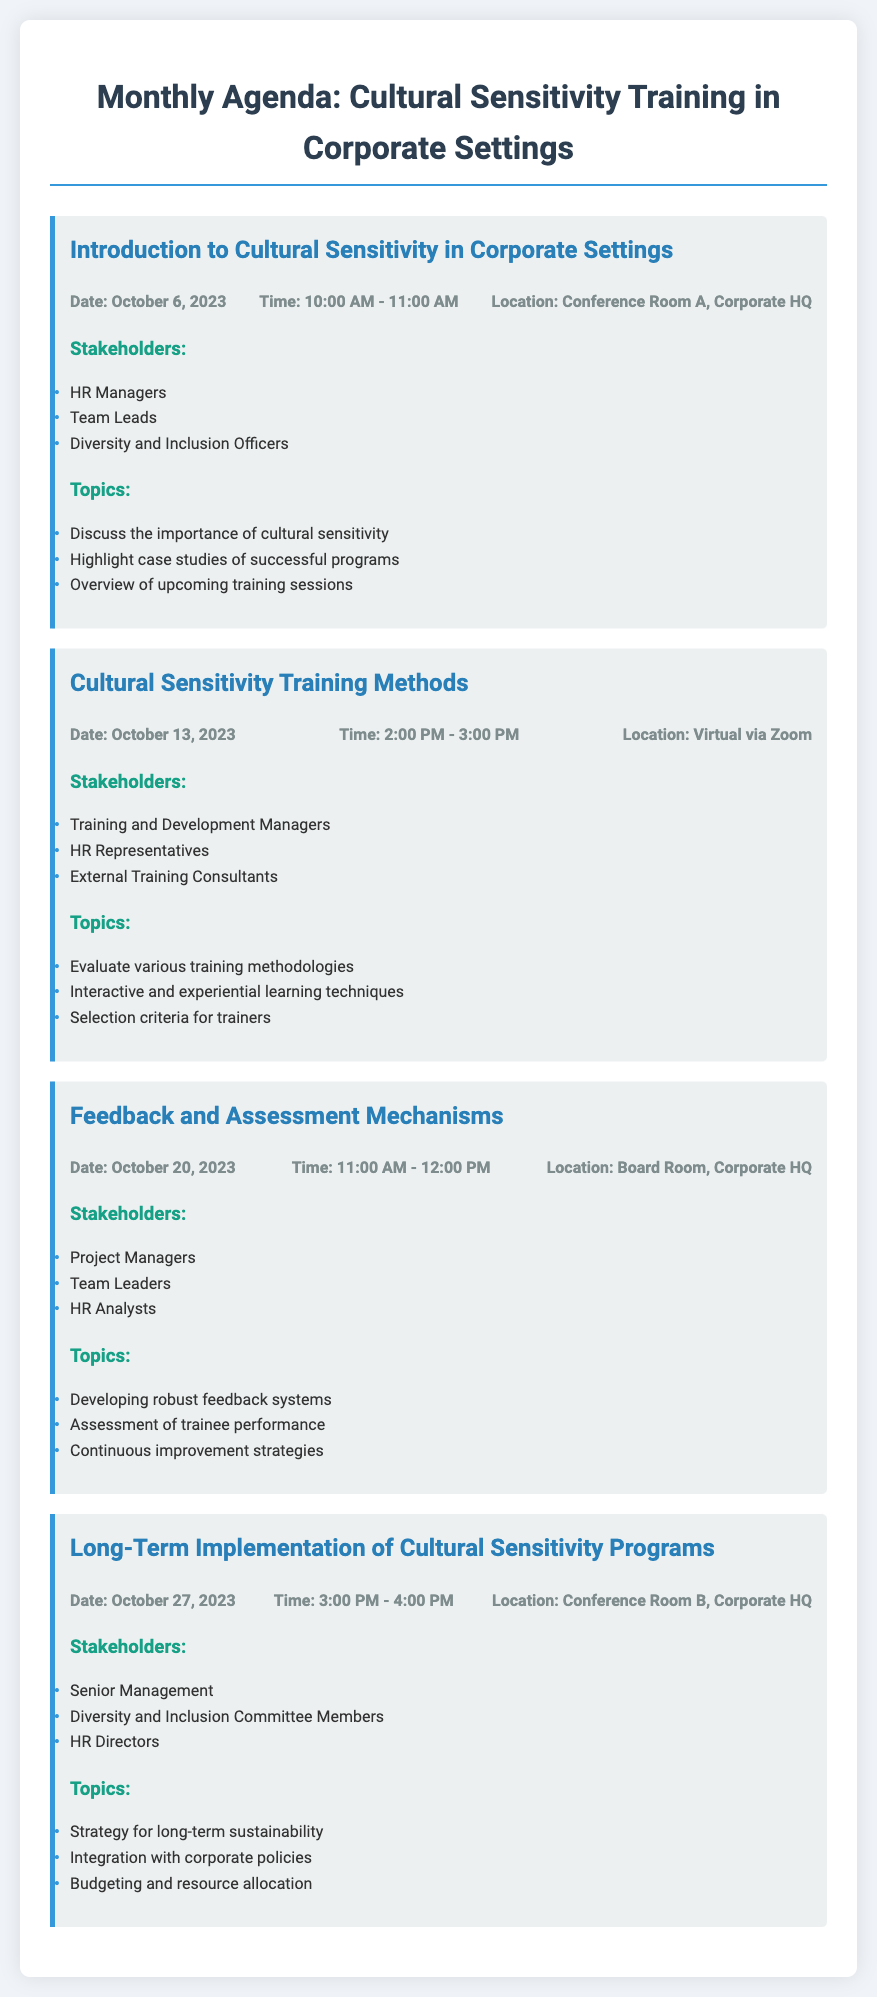What is the date of the first meeting? The first meeting is scheduled for October 6, 2023, as mentioned in the document.
Answer: October 6, 2023 Who is responsible for leading the second meeting? The second meeting involves Training and Development Managers, HR Representatives, and External Training Consultants, indicating leadership roles.
Answer: Training and Development Managers What is the location of the third meeting? The document specifies that the third meeting will take place in the Board Room at Corporate HQ.
Answer: Board Room, Corporate HQ What time is the last meeting scheduled for? The last meeting is noted to occur at 3:00 PM - 4:00 PM on October 27, 2023.
Answer: 3:00 PM - 4:00 PM Which stakeholders are involved in the first meeting? The first meeting includes HR Managers, Team Leads, and Diversity and Inclusion Officers as stakeholders.
Answer: HR Managers, Team Leads, Diversity and Inclusion Officers What is one of the main topics discussed in the second meeting? The second meeting discusses the evaluation of various training methodologies as one of its primary topics.
Answer: Evaluate various training methodologies How many meetings are listed in the agenda? The document outlines four meetings that are part of the monthly agenda.
Answer: Four What is a focus of the marketing of long-term implementation? The long-term implementation meeting focuses on strategies for sustainability, as indicated in the agenda.
Answer: Strategy for long-term sustainability 